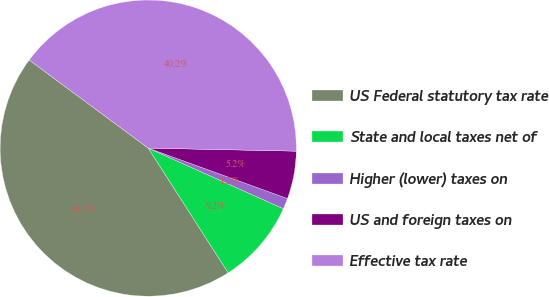Convert chart. <chart><loc_0><loc_0><loc_500><loc_500><pie_chart><fcel>US Federal statutory tax rate<fcel>State and local taxes net of<fcel>Higher (lower) taxes on<fcel>US and foreign taxes on<fcel>Effective tax rate<nl><fcel>44.21%<fcel>9.22%<fcel>1.18%<fcel>5.2%<fcel>40.19%<nl></chart> 